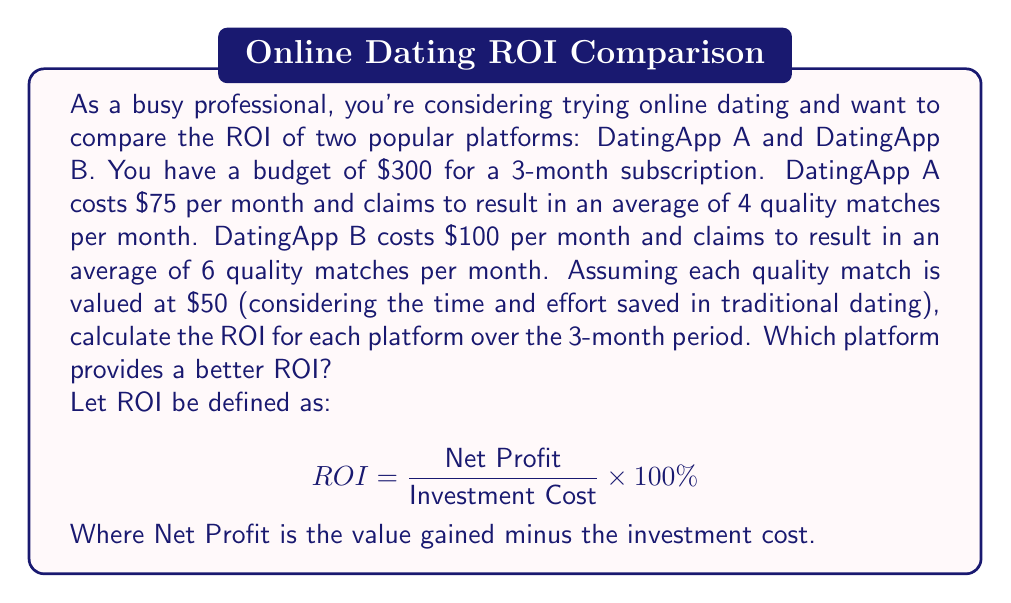Provide a solution to this math problem. Let's calculate the ROI for each dating app:

1. DatingApp A:
   - Investment Cost: $75 × 3 months = $225
   - Value Gained: 4 matches/month × 3 months × $50/match = $600
   - Net Profit: $600 - $225 = $375
   - ROI: $$ ROI_A = \frac{375}{225} \times 100\% = 166.67\% $$

2. DatingApp B:
   - Investment Cost: $100 × 3 months = $300
   - Value Gained: 6 matches/month × 3 months × $50/match = $900
   - Net Profit: $900 - $300 = $600
   - ROI: $$ ROI_B = \frac{600}{300} \times 100\% = 200\% $$

Comparing the two ROIs:
DatingApp A: 166.67%
DatingApp B: 200%

DatingApp B provides a better ROI, with a 33.33 percentage point difference.
Answer: DatingApp B provides a better ROI at 200%, compared to DatingApp A's 166.67%. The difference in ROI is 33.33 percentage points. 